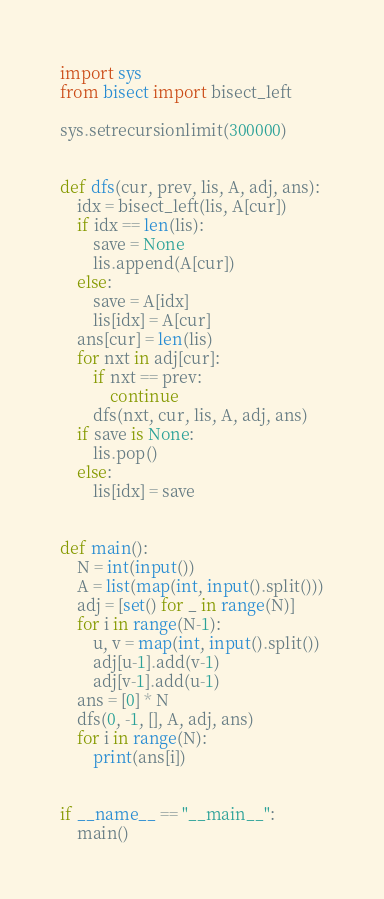<code> <loc_0><loc_0><loc_500><loc_500><_Python_>import sys
from bisect import bisect_left

sys.setrecursionlimit(300000)


def dfs(cur, prev, lis, A, adj, ans):
    idx = bisect_left(lis, A[cur])
    if idx == len(lis):
        save = None
        lis.append(A[cur])
    else:
        save = A[idx]
        lis[idx] = A[cur]
    ans[cur] = len(lis)
    for nxt in adj[cur]:
        if nxt == prev:
            continue
        dfs(nxt, cur, lis, A, adj, ans)
    if save is None:
        lis.pop()
    else:
        lis[idx] = save


def main():
    N = int(input())
    A = list(map(int, input().split()))
    adj = [set() for _ in range(N)]
    for i in range(N-1):
        u, v = map(int, input().split())
        adj[u-1].add(v-1)
        adj[v-1].add(u-1)
    ans = [0] * N
    dfs(0, -1, [], A, adj, ans)
    for i in range(N):
        print(ans[i])


if __name__ == "__main__":
    main()
</code> 